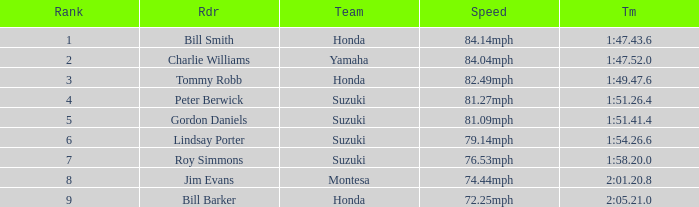Which rider had a time of 1:54.26.6? Lindsay Porter. 